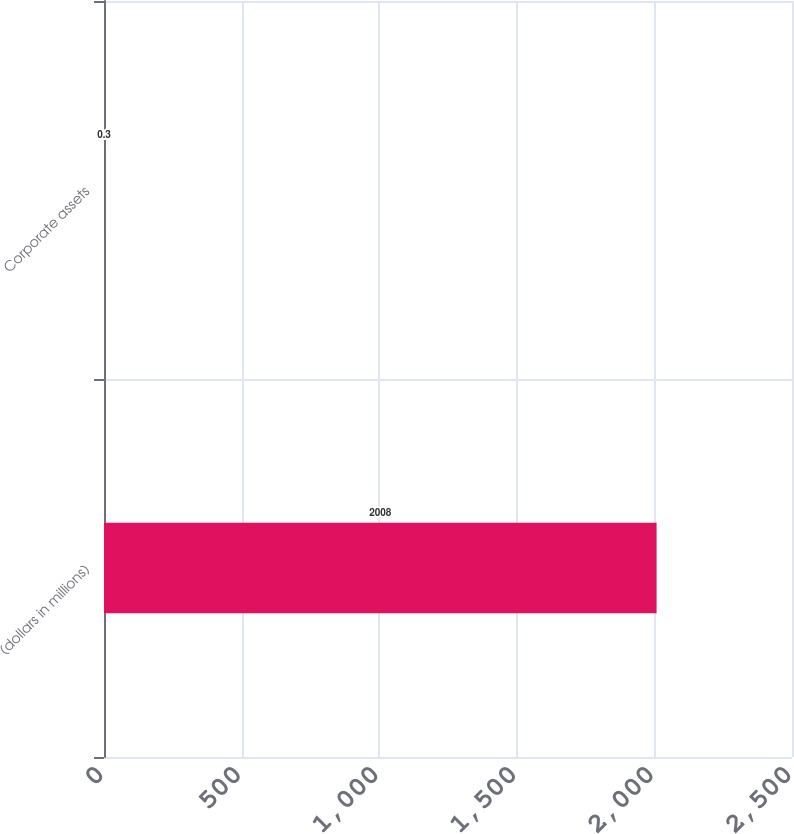Convert chart to OTSL. <chart><loc_0><loc_0><loc_500><loc_500><bar_chart><fcel>(dollars in millions)<fcel>Corporate assets<nl><fcel>2008<fcel>0.3<nl></chart> 